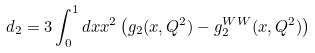Convert formula to latex. <formula><loc_0><loc_0><loc_500><loc_500>d _ { 2 } = 3 \int _ { 0 } ^ { 1 } d x x ^ { 2 } \left ( g _ { 2 } ( x , Q ^ { 2 } ) - g _ { 2 } ^ { W W } ( x , Q ^ { 2 } ) \right )</formula> 